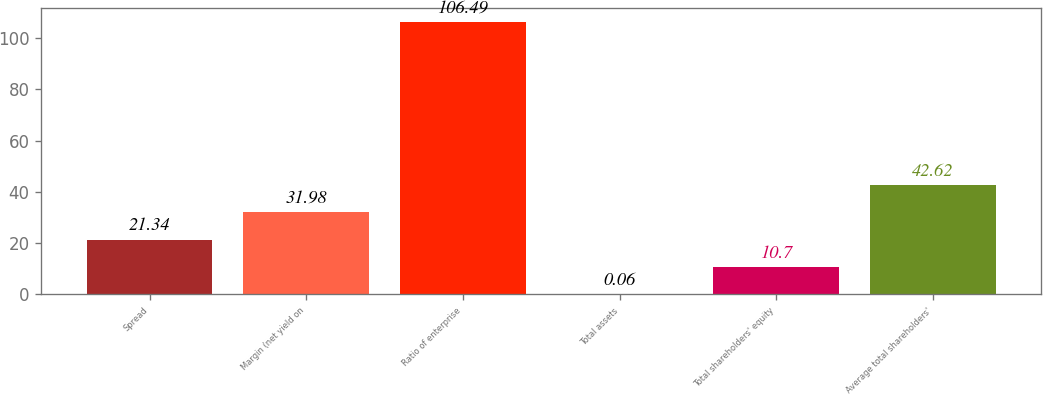Convert chart. <chart><loc_0><loc_0><loc_500><loc_500><bar_chart><fcel>Spread<fcel>Margin (net yield on<fcel>Ratio of enterprise<fcel>Total assets<fcel>Total shareholders' equity<fcel>Average total shareholders'<nl><fcel>21.34<fcel>31.98<fcel>106.49<fcel>0.06<fcel>10.7<fcel>42.62<nl></chart> 